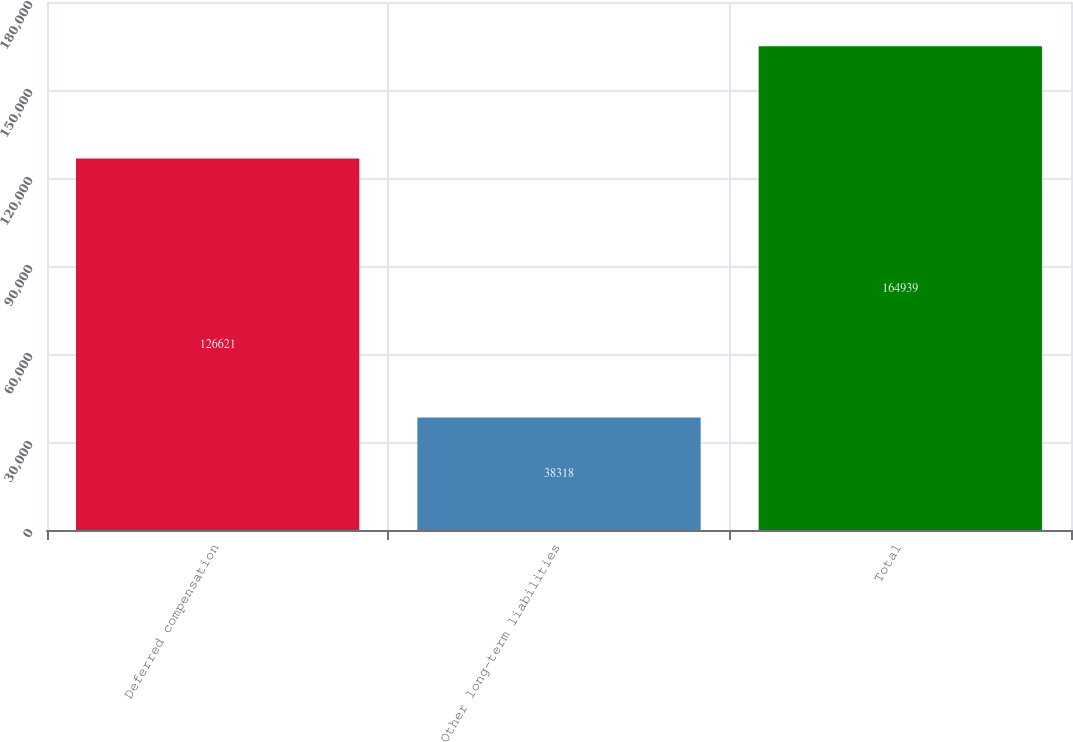<chart> <loc_0><loc_0><loc_500><loc_500><bar_chart><fcel>Deferred compensation<fcel>Other long-term liabilities<fcel>Total<nl><fcel>126621<fcel>38318<fcel>164939<nl></chart> 